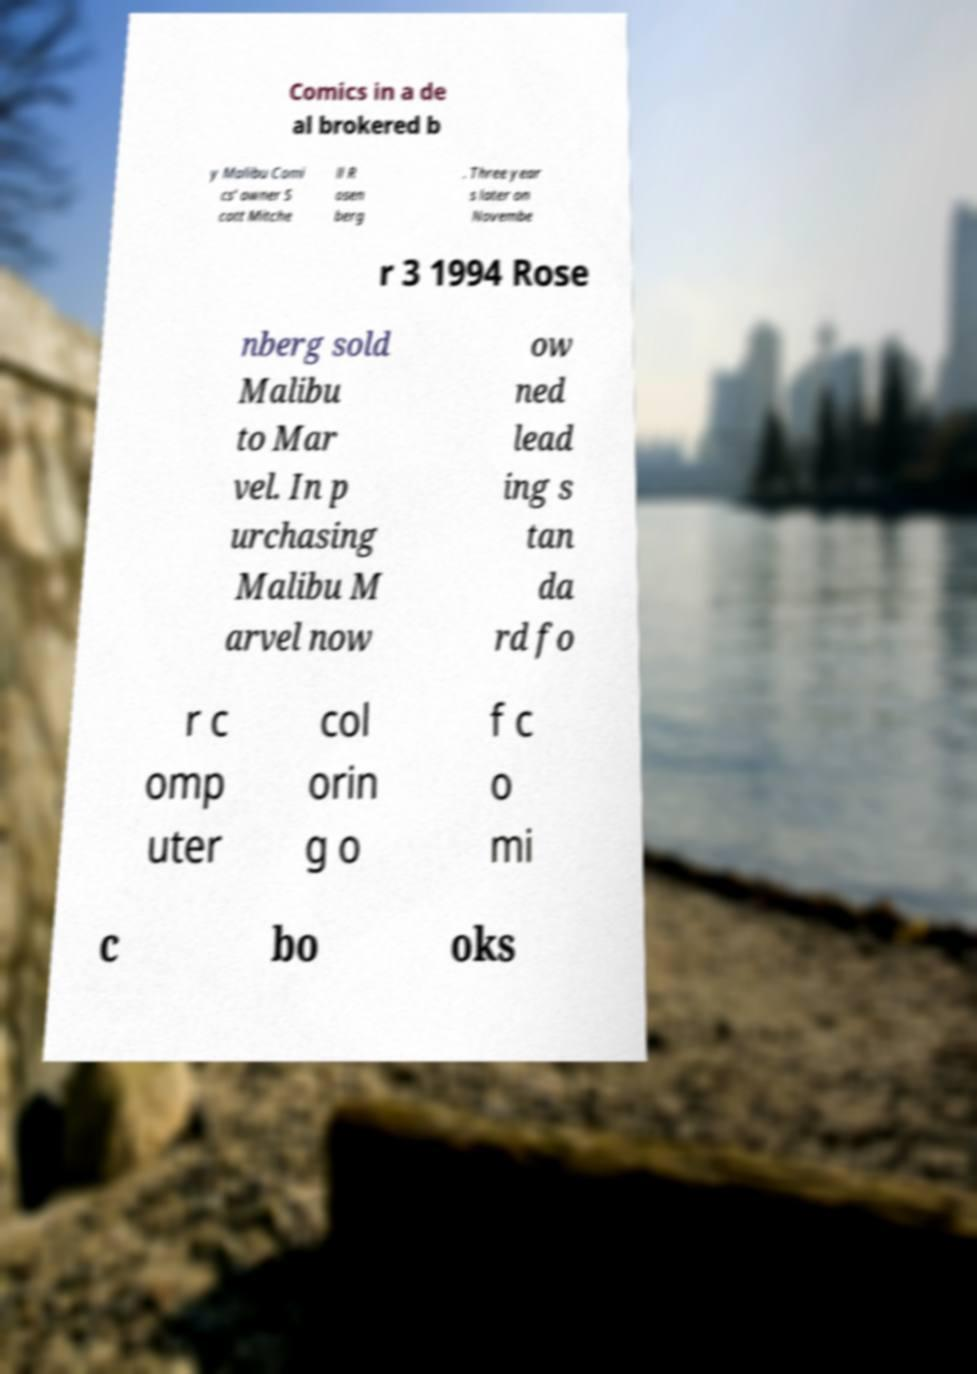Please read and relay the text visible in this image. What does it say? Comics in a de al brokered b y Malibu Comi cs' owner S cott Mitche ll R osen berg . Three year s later on Novembe r 3 1994 Rose nberg sold Malibu to Mar vel. In p urchasing Malibu M arvel now ow ned lead ing s tan da rd fo r c omp uter col orin g o f c o mi c bo oks 